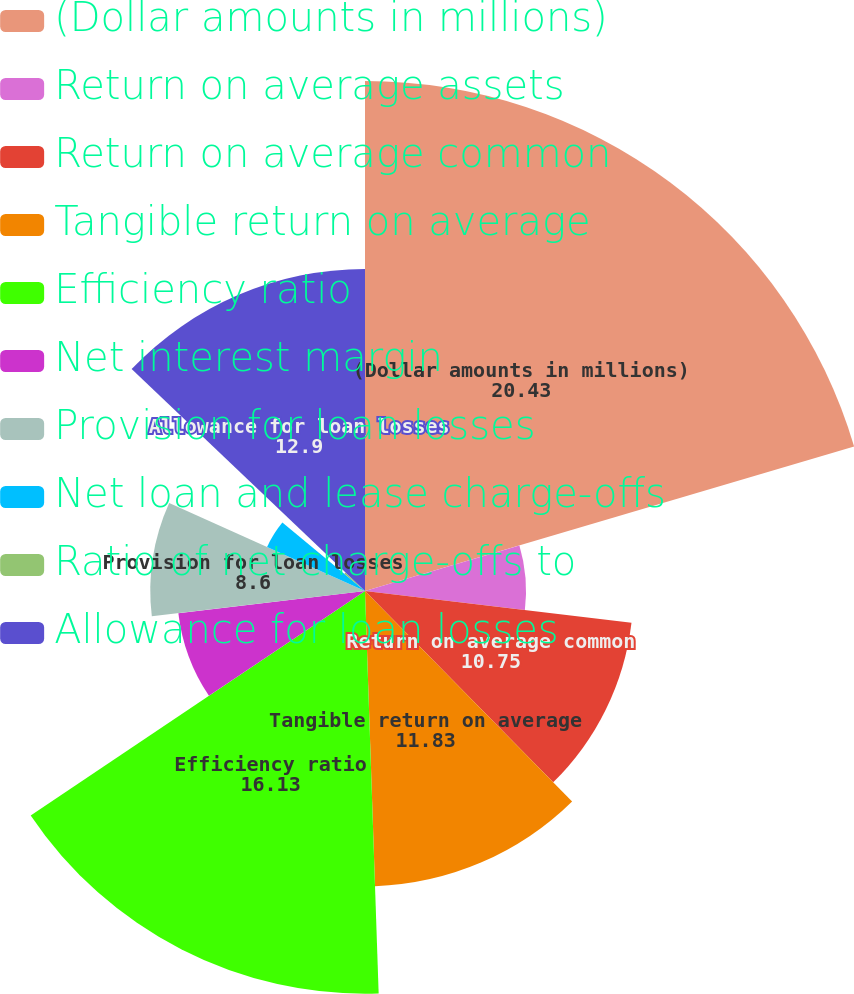Convert chart. <chart><loc_0><loc_0><loc_500><loc_500><pie_chart><fcel>(Dollar amounts in millions)<fcel>Return on average assets<fcel>Return on average common<fcel>Tangible return on average<fcel>Efficiency ratio<fcel>Net interest margin<fcel>Provision for loan losses<fcel>Net loan and lease charge-offs<fcel>Ratio of net charge-offs to<fcel>Allowance for loan losses<nl><fcel>20.43%<fcel>6.45%<fcel>10.75%<fcel>11.83%<fcel>16.13%<fcel>7.53%<fcel>8.6%<fcel>4.3%<fcel>1.08%<fcel>12.9%<nl></chart> 